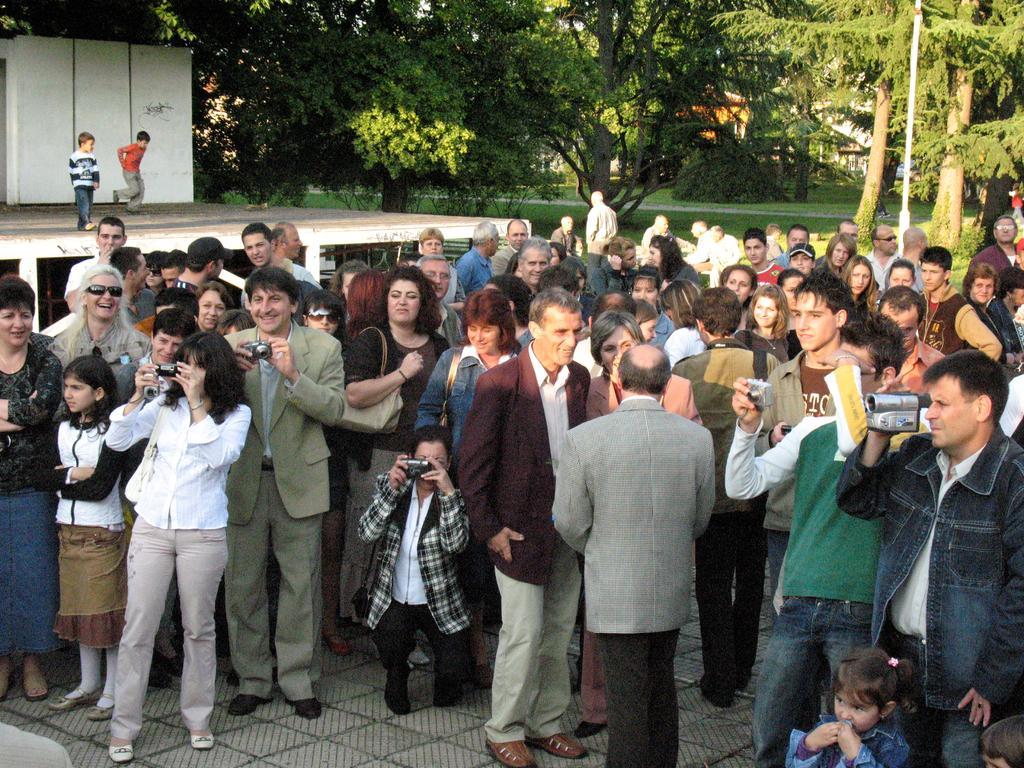Could you give a brief overview of what you see in this image? In the picture I can see group of people standing and some are holding cameras in their hands and in the background there are two kids dancing on stage, there are some trees, houses. 